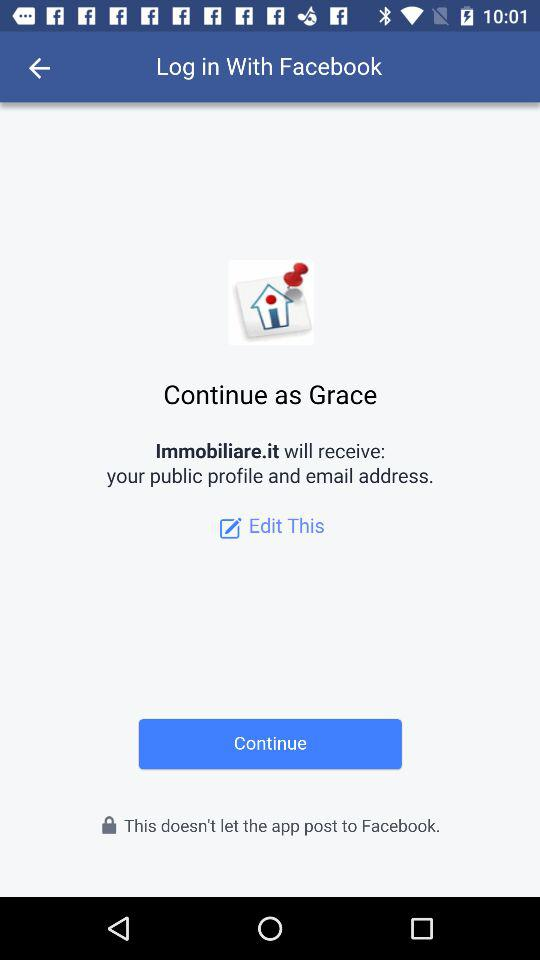What's the user name? The user name is Grace. 